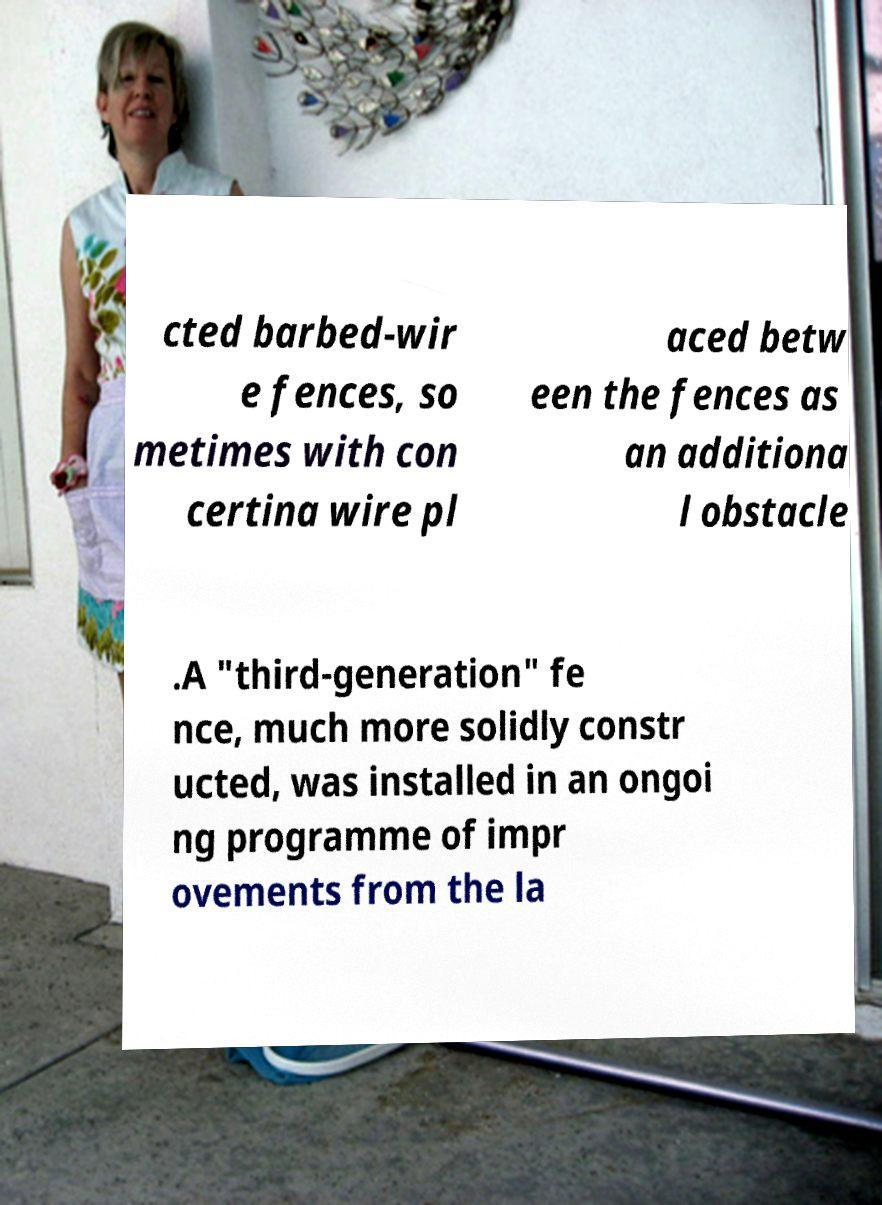Could you extract and type out the text from this image? cted barbed-wir e fences, so metimes with con certina wire pl aced betw een the fences as an additiona l obstacle .A "third-generation" fe nce, much more solidly constr ucted, was installed in an ongoi ng programme of impr ovements from the la 